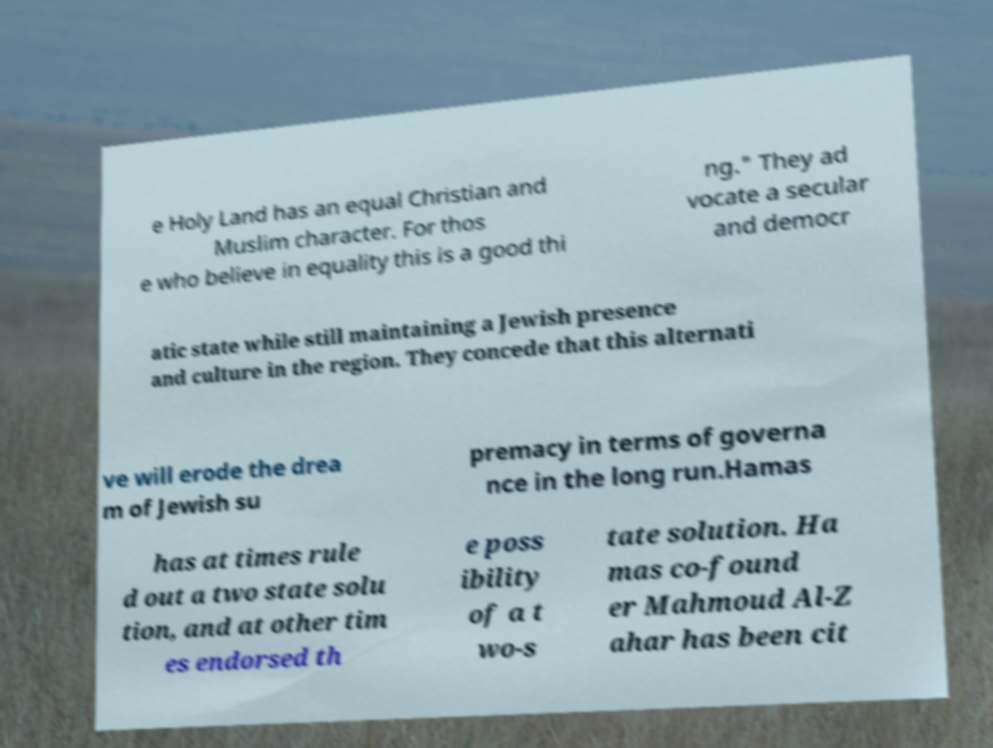Please identify and transcribe the text found in this image. e Holy Land has an equal Christian and Muslim character. For thos e who believe in equality this is a good thi ng." They ad vocate a secular and democr atic state while still maintaining a Jewish presence and culture in the region. They concede that this alternati ve will erode the drea m of Jewish su premacy in terms of governa nce in the long run.Hamas has at times rule d out a two state solu tion, and at other tim es endorsed th e poss ibility of a t wo-s tate solution. Ha mas co-found er Mahmoud Al-Z ahar has been cit 